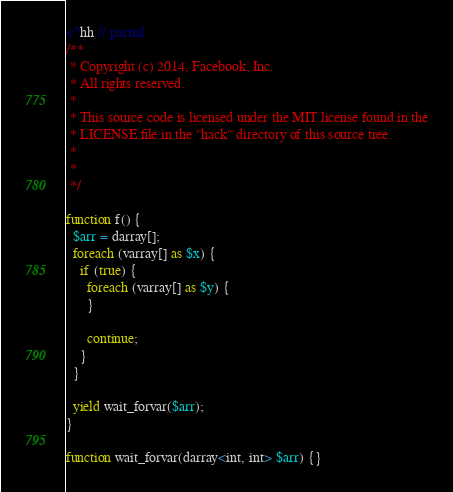Convert code to text. <code><loc_0><loc_0><loc_500><loc_500><_PHP_><?hh // partial
/**
 * Copyright (c) 2014, Facebook, Inc.
 * All rights reserved.
 *
 * This source code is licensed under the MIT license found in the
 * LICENSE file in the "hack" directory of this source tree.
 *
 *
 */

function f() {
  $arr = darray[];
  foreach (varray[] as $x) {
    if (true) {
      foreach (varray[] as $y) {
      }

      continue;
    }
  }

  yield wait_forvar($arr);
}

function wait_forvar(darray<int, int> $arr) {}
</code> 